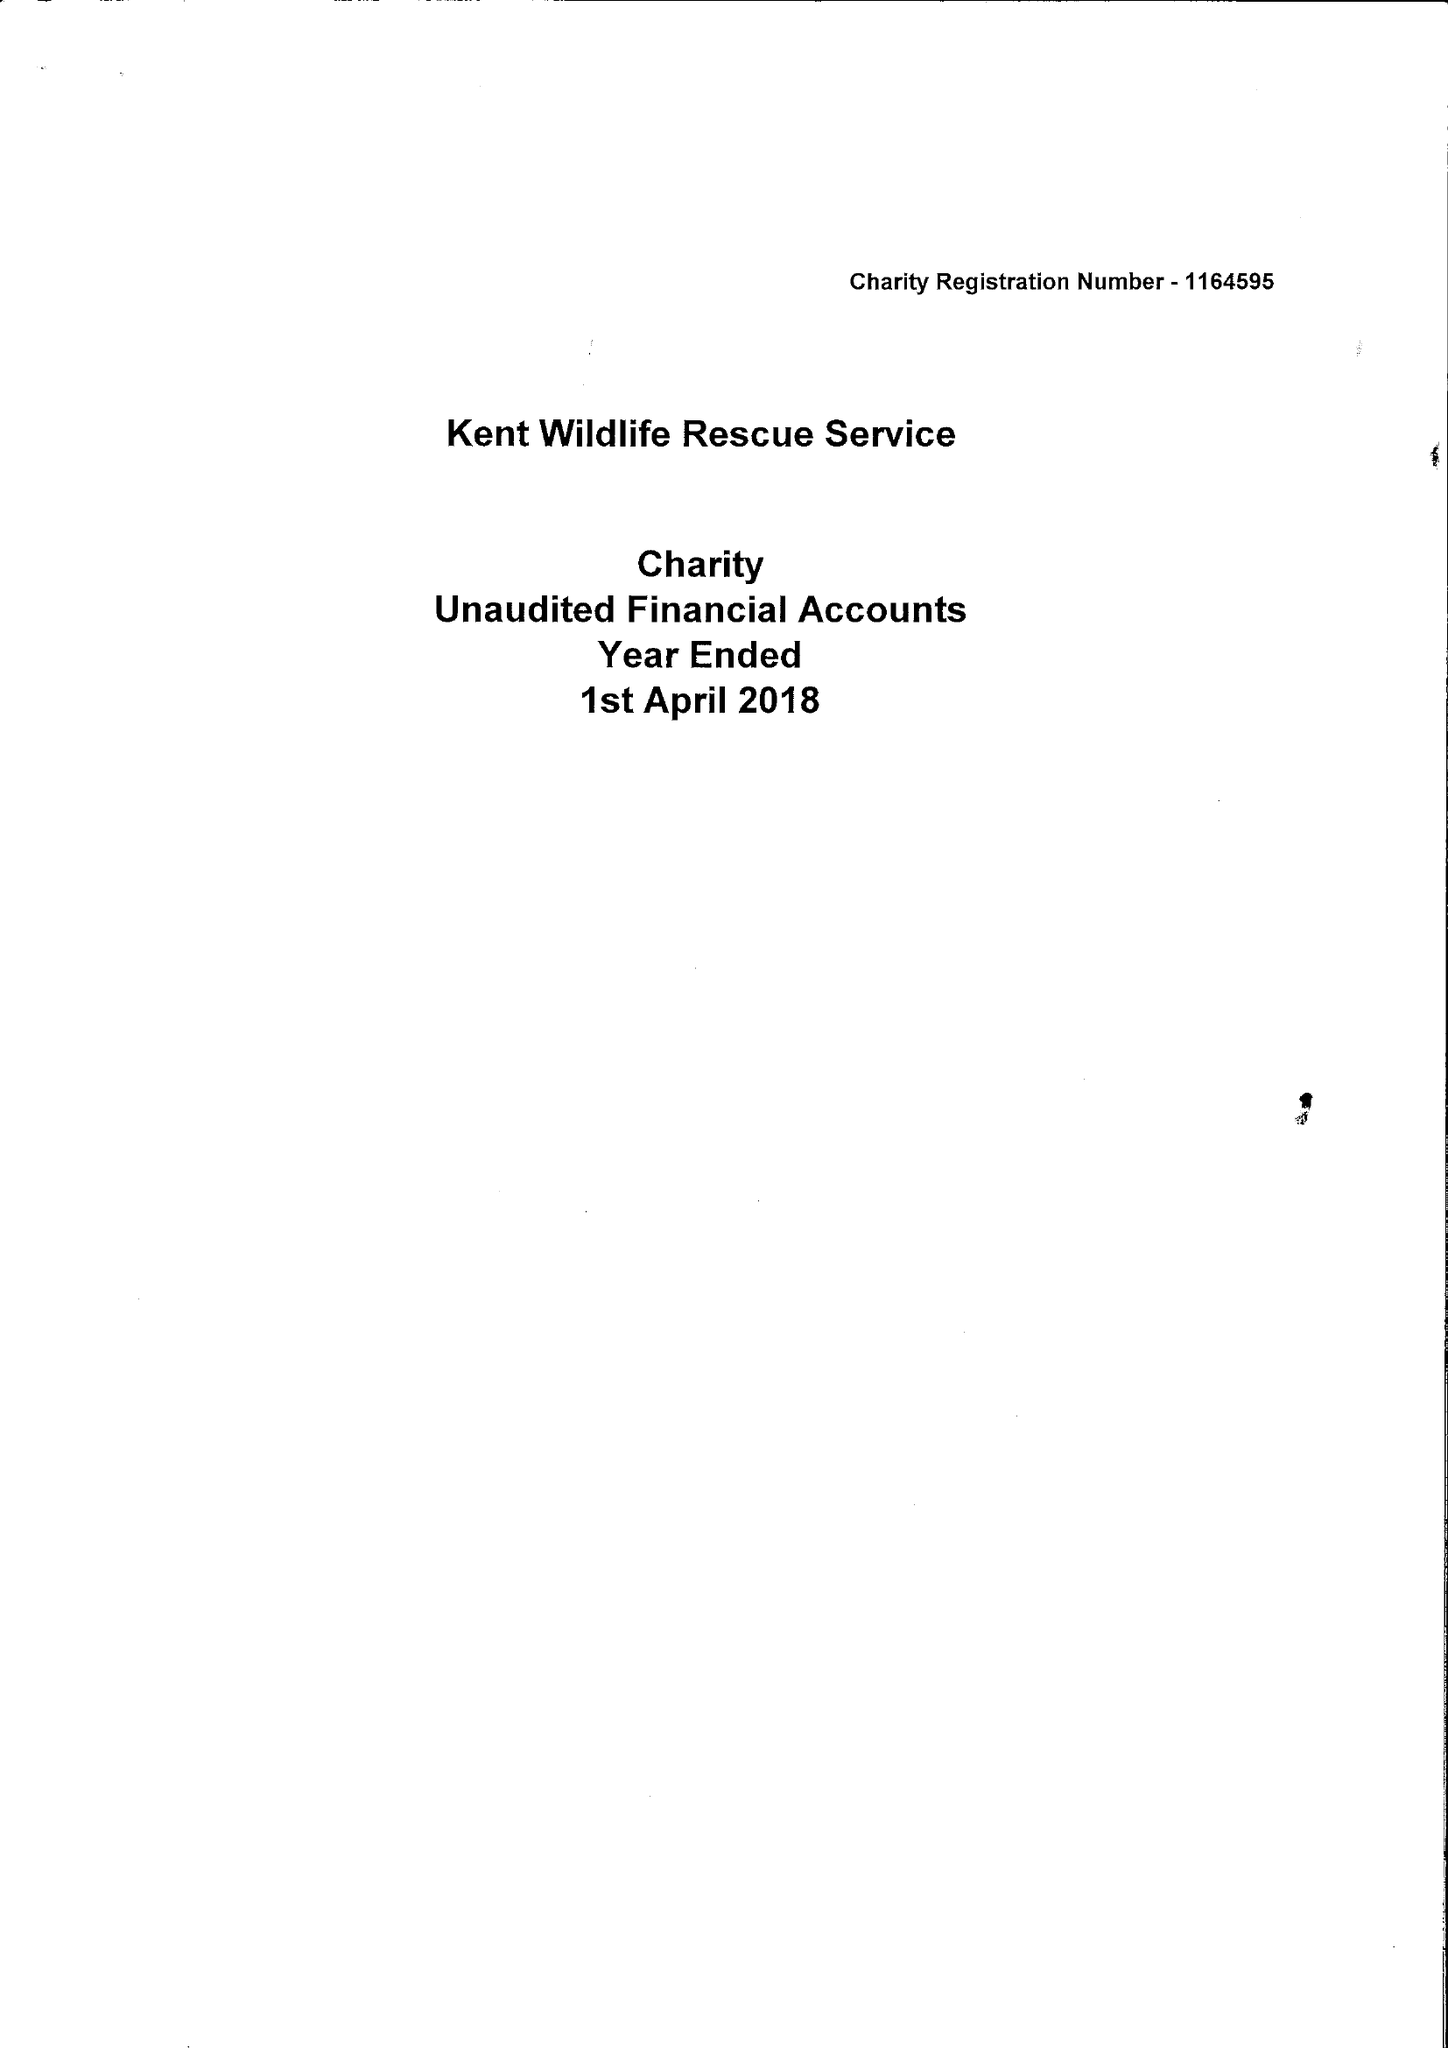What is the value for the charity_number?
Answer the question using a single word or phrase. 1164595 